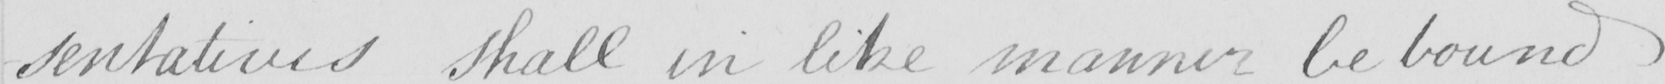Transcribe the text shown in this historical manuscript line. -sentatives shall in like manner be bound 